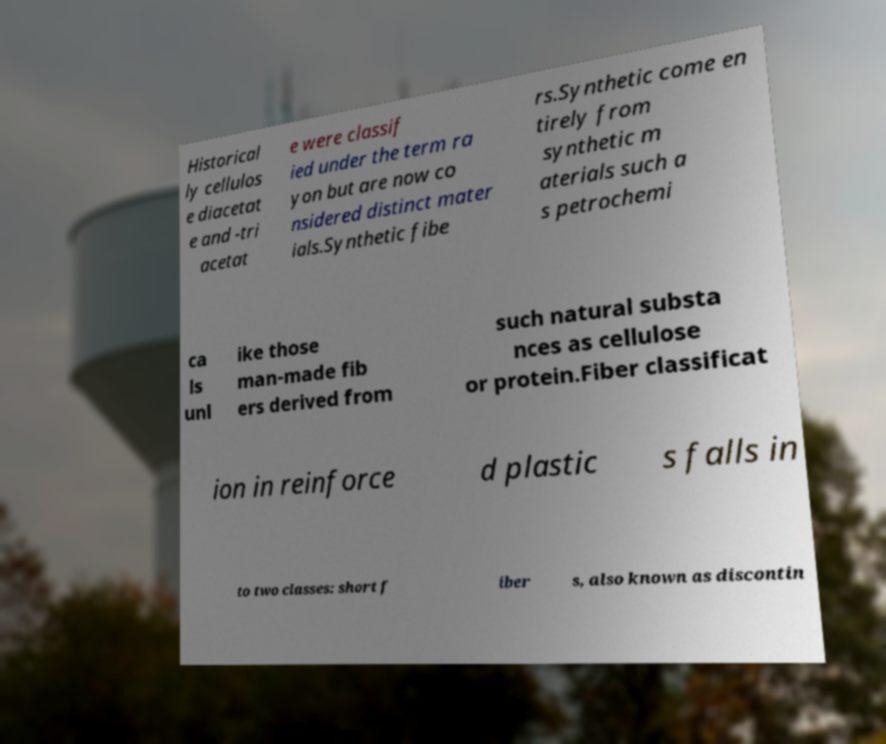For documentation purposes, I need the text within this image transcribed. Could you provide that? Historical ly cellulos e diacetat e and -tri acetat e were classif ied under the term ra yon but are now co nsidered distinct mater ials.Synthetic fibe rs.Synthetic come en tirely from synthetic m aterials such a s petrochemi ca ls unl ike those man-made fib ers derived from such natural substa nces as cellulose or protein.Fiber classificat ion in reinforce d plastic s falls in to two classes: short f iber s, also known as discontin 